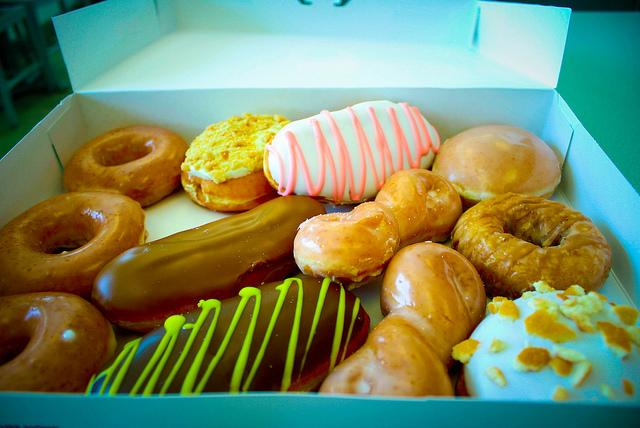What treat is in the box? donuts 